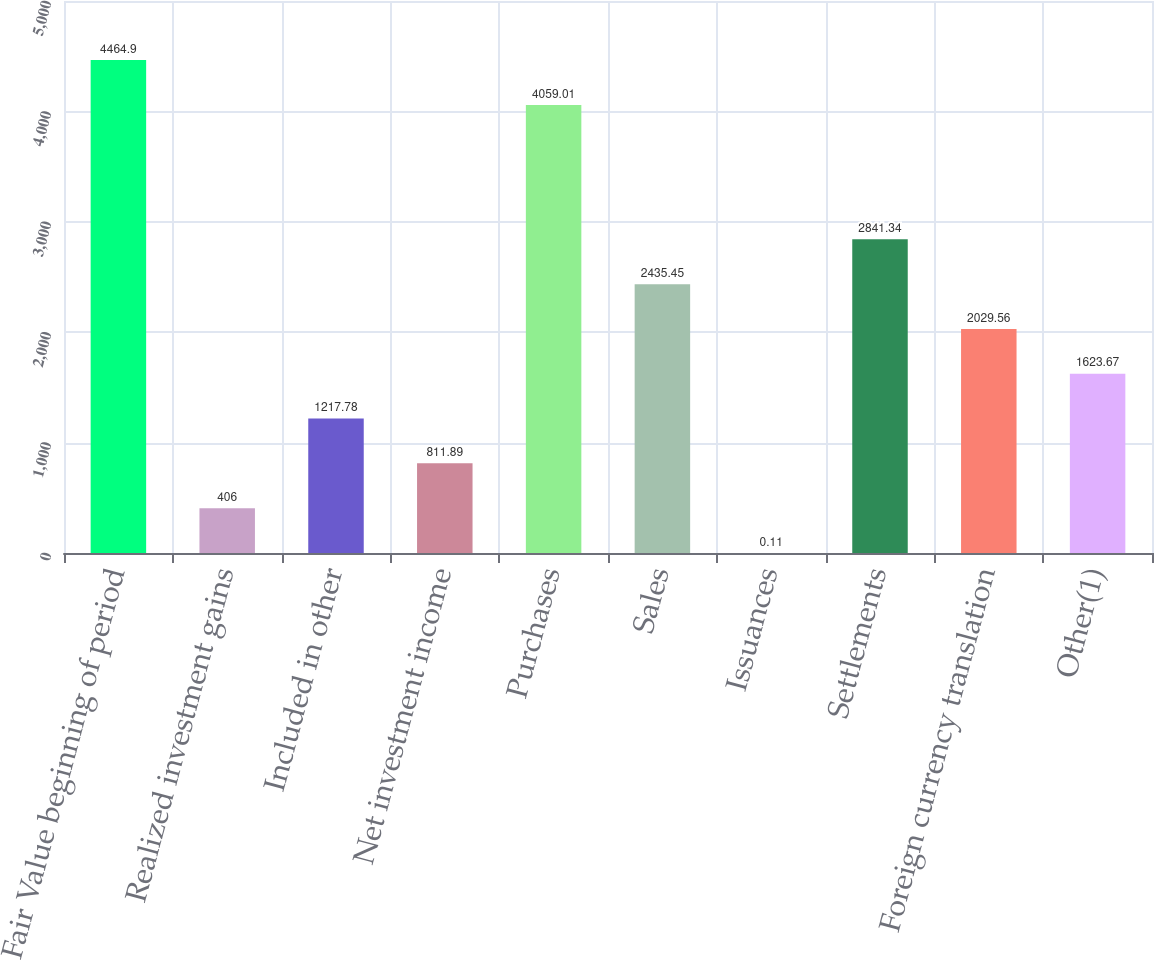Convert chart. <chart><loc_0><loc_0><loc_500><loc_500><bar_chart><fcel>Fair Value beginning of period<fcel>Realized investment gains<fcel>Included in other<fcel>Net investment income<fcel>Purchases<fcel>Sales<fcel>Issuances<fcel>Settlements<fcel>Foreign currency translation<fcel>Other(1)<nl><fcel>4464.9<fcel>406<fcel>1217.78<fcel>811.89<fcel>4059.01<fcel>2435.45<fcel>0.11<fcel>2841.34<fcel>2029.56<fcel>1623.67<nl></chart> 